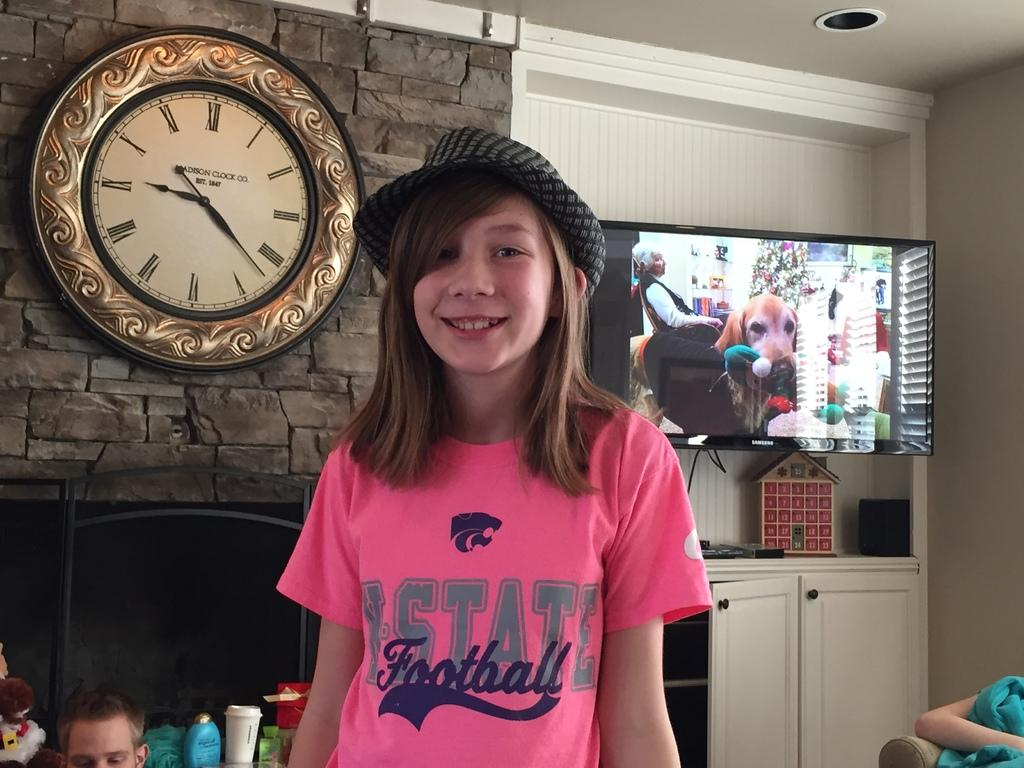<image>
Summarize the visual content of the image. The young girl is wearing a pink t-shirt letting her know she's a fan of a state football team. 